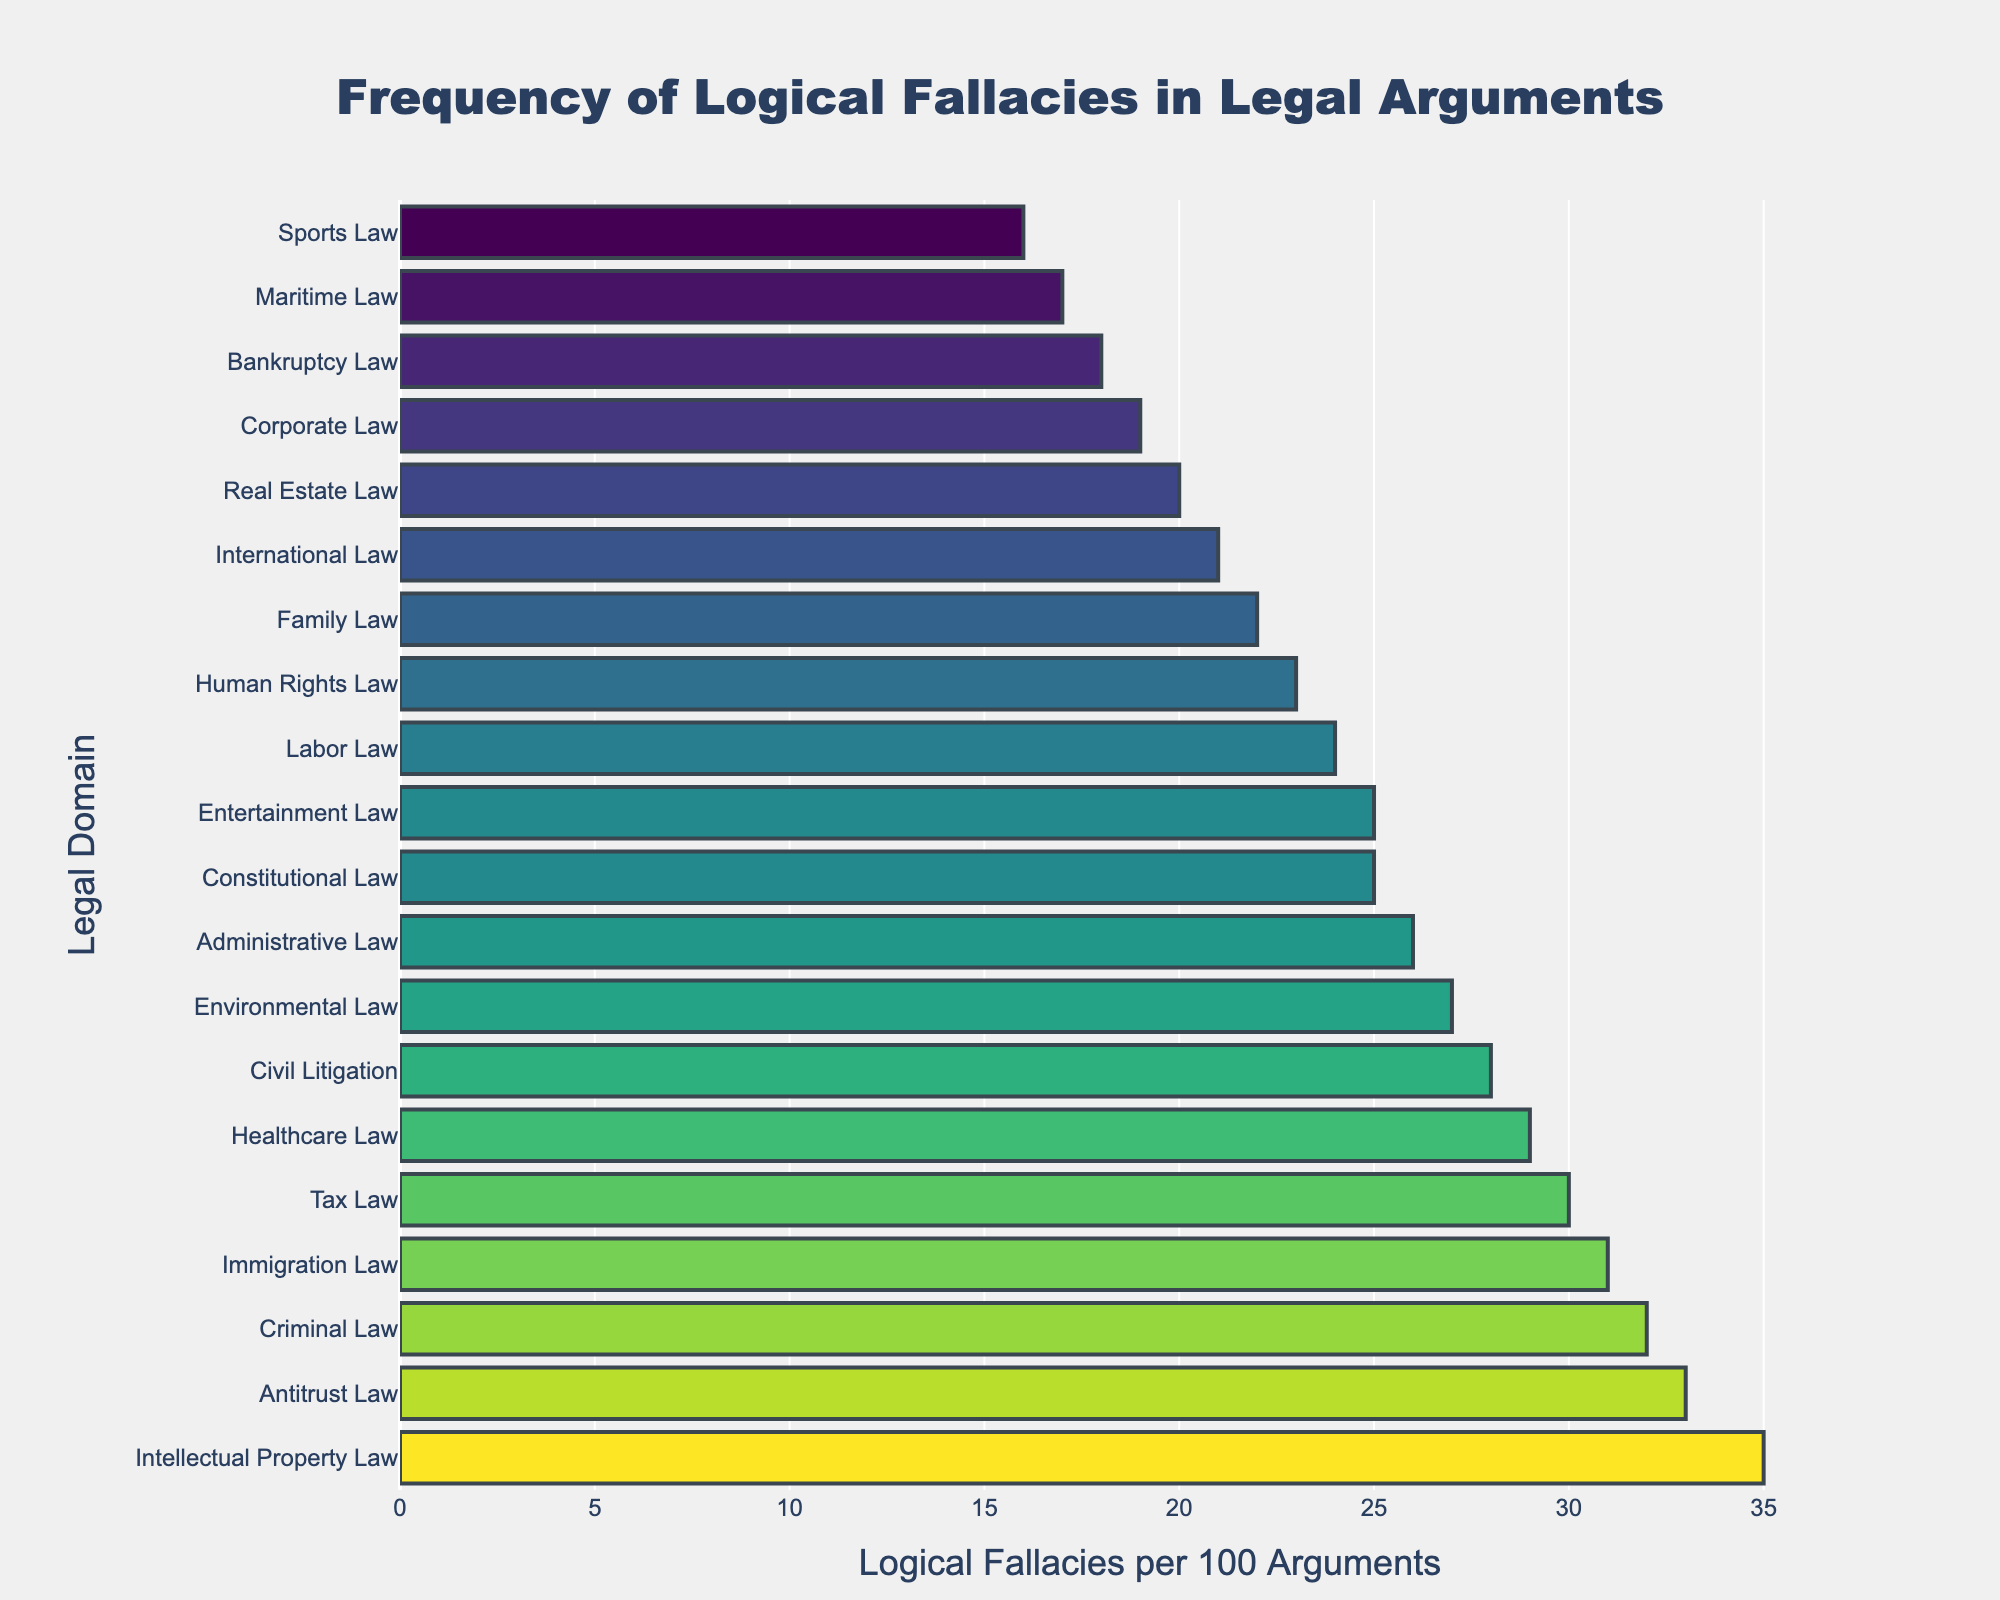What's the highest frequency of logical fallacies identified in a legal domain, and which domain does it belong to? The bar with the highest value along the x-axis represents the domain with the highest frequency of logical fallacies. By observing the figure, Intellectual Property Law shows 35 logical fallacies per 100 arguments, which is the highest.
Answer: 35 in Intellectual Property Law Which legal domain has the least frequency of logical fallacies? The bar with the shortest length indicates the legal domain with the lowest frequency of logical fallacies. The shortest bar corresponds to Sports Law, which shows 16 logical fallacies per 100 arguments.
Answer: Sports Law What is the average frequency of logical fallacies across all legal domains? To find the average, sum up the logical fallacy counts of all legal domains and divide by the number of domains. (32+28+25+22+19+35+27+24+30+21+26+23+29+31+20+18+33+17+16+25)/20 = 26.05
Answer: 26.05 Which legal domains have a frequency of logical fallacies greater than 30? Identify bars that extend past the 30 mark on the x-axis. The legal domains with fallacies greater than 30 are Criminal Law (32), Tax Law (30), Immigration Law (31), Antitrust Law (33), and Intellectual Property Law (35).
Answer: Criminal Law, Immigration Law, Antitrust Law, Intellectual Property Law How much more frequent are logical fallacies in Criminal Law compared to Maritime Law? Subtract Maritime Law's frequency from Criminal Law's frequency. Criminal Law has 32, and Maritime Law has 17. The difference is 32 - 17 = 15.
Answer: 15 Which legal domains have a frequency of logical fallacies equal to Healthcare Law? Find the bar with the same length as the one representing Healthcare Law. Healthcare Law has 29. No other legal domain matches this frequency exactly.
Answer: None What is the median frequency of logical fallacies across all legal domains? List the frequencies in ascending order and find the middle value, or the average of the two middle values if there are an even number of domains. The sorted values are: 16, 17, 18, 19, 20, 21, 22, 23, 24, 25, 25, 26, 27, 28, 29, 30, 31, 32, 33, 35. The middle values are 25 and 26, so the median is (25+26)/2 = 25.5
Answer: 25.5 By how much does the frequency of logical fallacies in Family Law exceed that in International Law? Subtract International Law's frequency from Family Law's frequency. Family Law has 22, and International Law has 21. The difference is 22 - 21 = 1.
Answer: 1 Identify the legal domains where the frequency of logical fallacies falls between 20 and 30. Locate the bars that fall within the range of 20 to 30 on the x-axis. The corresponding legal domains are Civil Litigation (28), Administrative Law (26), Environmental Law (27), Healthcare Law (29), Family Law (22), Human Rights Law (23), Labor Law (24), Constitutional Law (25), International Law (21), Real Estate Law (20), Tax Law (30), and Entertainment Law (25).
Answer: Civil Litigation, Administrative Law, Environmental Law, Healthcare Law, Family Law, Human Rights Law, Labor Law, Constitutional Law, International Law, Real Estate Law, Tax Law, Entertainment Law What is the total frequency of logical fallacies for Corporate Law, Healthcare Law, and Tax Law combined? Add the frequencies of the mentioned legal domains. Corporate Law has 19, Healthcare Law has 29, and Tax Law has 30. The combined total is 19 + 29 + 30 = 78.
Answer: 78 